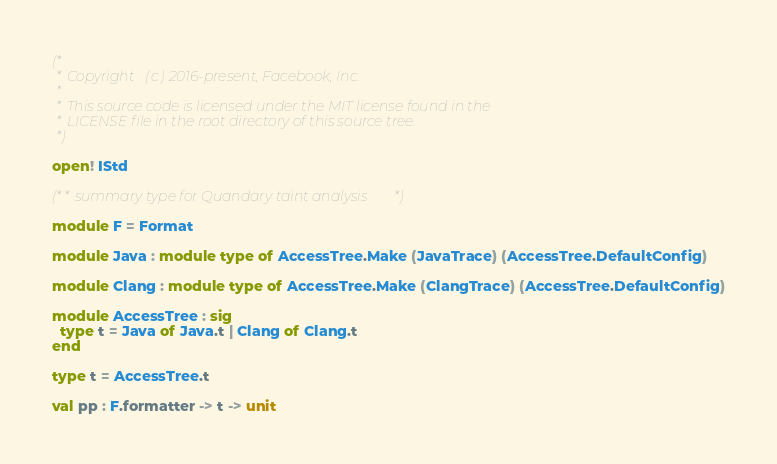Convert code to text. <code><loc_0><loc_0><loc_500><loc_500><_OCaml_>(*
 * Copyright (c) 2016-present, Facebook, Inc.
 *
 * This source code is licensed under the MIT license found in the
 * LICENSE file in the root directory of this source tree.
 *)

open! IStd

(** summary type for Quandary taint analysis *)

module F = Format

module Java : module type of AccessTree.Make (JavaTrace) (AccessTree.DefaultConfig)

module Clang : module type of AccessTree.Make (ClangTrace) (AccessTree.DefaultConfig)

module AccessTree : sig
  type t = Java of Java.t | Clang of Clang.t
end

type t = AccessTree.t

val pp : F.formatter -> t -> unit
</code> 